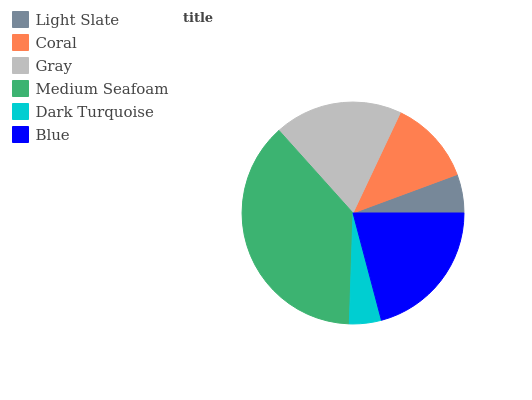Is Dark Turquoise the minimum?
Answer yes or no. Yes. Is Medium Seafoam the maximum?
Answer yes or no. Yes. Is Coral the minimum?
Answer yes or no. No. Is Coral the maximum?
Answer yes or no. No. Is Coral greater than Light Slate?
Answer yes or no. Yes. Is Light Slate less than Coral?
Answer yes or no. Yes. Is Light Slate greater than Coral?
Answer yes or no. No. Is Coral less than Light Slate?
Answer yes or no. No. Is Gray the high median?
Answer yes or no. Yes. Is Coral the low median?
Answer yes or no. Yes. Is Coral the high median?
Answer yes or no. No. Is Gray the low median?
Answer yes or no. No. 